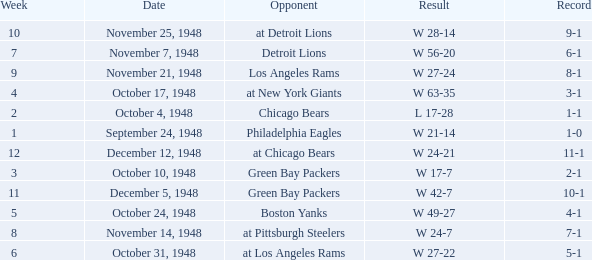What date was the opponent the Boston Yanks? October 24, 1948. 